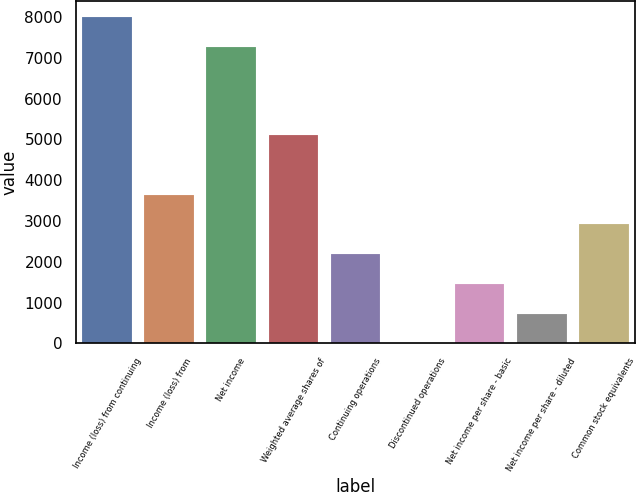Convert chart. <chart><loc_0><loc_0><loc_500><loc_500><bar_chart><fcel>Income (loss) from continuing<fcel>Income (loss) from<fcel>Net income<fcel>Weighted average shares of<fcel>Continuing operations<fcel>Discontinued operations<fcel>Net income per share - basic<fcel>Net income per share - diluted<fcel>Common stock equivalents<nl><fcel>7994.5<fcel>3642.52<fcel>7266<fcel>5099.52<fcel>2185.52<fcel>0.02<fcel>1457.02<fcel>728.52<fcel>2914.02<nl></chart> 